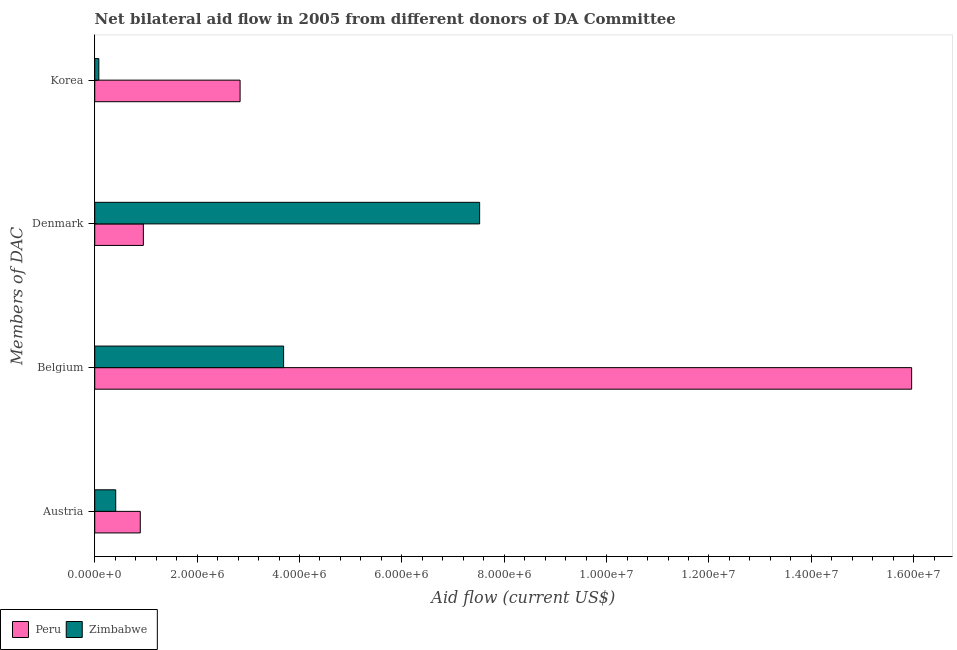How many different coloured bars are there?
Make the answer very short. 2. Are the number of bars per tick equal to the number of legend labels?
Provide a short and direct response. Yes. What is the amount of aid given by austria in Peru?
Make the answer very short. 8.90e+05. Across all countries, what is the maximum amount of aid given by korea?
Make the answer very short. 2.84e+06. Across all countries, what is the minimum amount of aid given by korea?
Your response must be concise. 8.00e+04. In which country was the amount of aid given by korea minimum?
Keep it short and to the point. Zimbabwe. What is the total amount of aid given by austria in the graph?
Ensure brevity in your answer.  1.30e+06. What is the difference between the amount of aid given by belgium in Zimbabwe and that in Peru?
Your answer should be very brief. -1.23e+07. What is the difference between the amount of aid given by korea in Zimbabwe and the amount of aid given by austria in Peru?
Make the answer very short. -8.10e+05. What is the average amount of aid given by denmark per country?
Offer a very short reply. 4.24e+06. What is the difference between the amount of aid given by korea and amount of aid given by austria in Peru?
Your response must be concise. 1.95e+06. In how many countries, is the amount of aid given by belgium greater than 4400000 US$?
Offer a very short reply. 1. What is the ratio of the amount of aid given by denmark in Peru to that in Zimbabwe?
Give a very brief answer. 0.13. Is the amount of aid given by denmark in Zimbabwe less than that in Peru?
Make the answer very short. No. What is the difference between the highest and the second highest amount of aid given by denmark?
Your answer should be compact. 6.57e+06. What is the difference between the highest and the lowest amount of aid given by belgium?
Ensure brevity in your answer.  1.23e+07. Is the sum of the amount of aid given by austria in Zimbabwe and Peru greater than the maximum amount of aid given by denmark across all countries?
Provide a succinct answer. No. What does the 2nd bar from the top in Denmark represents?
Provide a short and direct response. Peru. How many bars are there?
Provide a short and direct response. 8. Are all the bars in the graph horizontal?
Your response must be concise. Yes. What is the difference between two consecutive major ticks on the X-axis?
Make the answer very short. 2.00e+06. Does the graph contain any zero values?
Offer a terse response. No. Does the graph contain grids?
Offer a very short reply. No. Where does the legend appear in the graph?
Provide a short and direct response. Bottom left. How are the legend labels stacked?
Give a very brief answer. Horizontal. What is the title of the graph?
Offer a very short reply. Net bilateral aid flow in 2005 from different donors of DA Committee. Does "Kiribati" appear as one of the legend labels in the graph?
Give a very brief answer. No. What is the label or title of the Y-axis?
Keep it short and to the point. Members of DAC. What is the Aid flow (current US$) of Peru in Austria?
Make the answer very short. 8.90e+05. What is the Aid flow (current US$) in Zimbabwe in Austria?
Provide a short and direct response. 4.10e+05. What is the Aid flow (current US$) in Peru in Belgium?
Offer a very short reply. 1.60e+07. What is the Aid flow (current US$) of Zimbabwe in Belgium?
Make the answer very short. 3.69e+06. What is the Aid flow (current US$) of Peru in Denmark?
Offer a very short reply. 9.50e+05. What is the Aid flow (current US$) of Zimbabwe in Denmark?
Ensure brevity in your answer.  7.52e+06. What is the Aid flow (current US$) in Peru in Korea?
Provide a succinct answer. 2.84e+06. What is the Aid flow (current US$) of Zimbabwe in Korea?
Your answer should be compact. 8.00e+04. Across all Members of DAC, what is the maximum Aid flow (current US$) in Peru?
Your answer should be very brief. 1.60e+07. Across all Members of DAC, what is the maximum Aid flow (current US$) in Zimbabwe?
Ensure brevity in your answer.  7.52e+06. Across all Members of DAC, what is the minimum Aid flow (current US$) of Peru?
Provide a succinct answer. 8.90e+05. Across all Members of DAC, what is the minimum Aid flow (current US$) in Zimbabwe?
Offer a very short reply. 8.00e+04. What is the total Aid flow (current US$) of Peru in the graph?
Your response must be concise. 2.06e+07. What is the total Aid flow (current US$) in Zimbabwe in the graph?
Offer a very short reply. 1.17e+07. What is the difference between the Aid flow (current US$) of Peru in Austria and that in Belgium?
Give a very brief answer. -1.51e+07. What is the difference between the Aid flow (current US$) in Zimbabwe in Austria and that in Belgium?
Offer a terse response. -3.28e+06. What is the difference between the Aid flow (current US$) in Zimbabwe in Austria and that in Denmark?
Your answer should be compact. -7.11e+06. What is the difference between the Aid flow (current US$) of Peru in Austria and that in Korea?
Keep it short and to the point. -1.95e+06. What is the difference between the Aid flow (current US$) in Peru in Belgium and that in Denmark?
Your answer should be very brief. 1.50e+07. What is the difference between the Aid flow (current US$) of Zimbabwe in Belgium and that in Denmark?
Give a very brief answer. -3.83e+06. What is the difference between the Aid flow (current US$) in Peru in Belgium and that in Korea?
Keep it short and to the point. 1.31e+07. What is the difference between the Aid flow (current US$) of Zimbabwe in Belgium and that in Korea?
Give a very brief answer. 3.61e+06. What is the difference between the Aid flow (current US$) of Peru in Denmark and that in Korea?
Give a very brief answer. -1.89e+06. What is the difference between the Aid flow (current US$) in Zimbabwe in Denmark and that in Korea?
Make the answer very short. 7.44e+06. What is the difference between the Aid flow (current US$) of Peru in Austria and the Aid flow (current US$) of Zimbabwe in Belgium?
Your answer should be very brief. -2.80e+06. What is the difference between the Aid flow (current US$) of Peru in Austria and the Aid flow (current US$) of Zimbabwe in Denmark?
Provide a short and direct response. -6.63e+06. What is the difference between the Aid flow (current US$) in Peru in Austria and the Aid flow (current US$) in Zimbabwe in Korea?
Provide a short and direct response. 8.10e+05. What is the difference between the Aid flow (current US$) of Peru in Belgium and the Aid flow (current US$) of Zimbabwe in Denmark?
Provide a succinct answer. 8.44e+06. What is the difference between the Aid flow (current US$) of Peru in Belgium and the Aid flow (current US$) of Zimbabwe in Korea?
Your response must be concise. 1.59e+07. What is the difference between the Aid flow (current US$) of Peru in Denmark and the Aid flow (current US$) of Zimbabwe in Korea?
Provide a short and direct response. 8.70e+05. What is the average Aid flow (current US$) of Peru per Members of DAC?
Keep it short and to the point. 5.16e+06. What is the average Aid flow (current US$) in Zimbabwe per Members of DAC?
Offer a very short reply. 2.92e+06. What is the difference between the Aid flow (current US$) in Peru and Aid flow (current US$) in Zimbabwe in Belgium?
Offer a terse response. 1.23e+07. What is the difference between the Aid flow (current US$) in Peru and Aid flow (current US$) in Zimbabwe in Denmark?
Ensure brevity in your answer.  -6.57e+06. What is the difference between the Aid flow (current US$) in Peru and Aid flow (current US$) in Zimbabwe in Korea?
Give a very brief answer. 2.76e+06. What is the ratio of the Aid flow (current US$) in Peru in Austria to that in Belgium?
Make the answer very short. 0.06. What is the ratio of the Aid flow (current US$) of Peru in Austria to that in Denmark?
Your response must be concise. 0.94. What is the ratio of the Aid flow (current US$) in Zimbabwe in Austria to that in Denmark?
Your response must be concise. 0.05. What is the ratio of the Aid flow (current US$) in Peru in Austria to that in Korea?
Provide a succinct answer. 0.31. What is the ratio of the Aid flow (current US$) in Zimbabwe in Austria to that in Korea?
Ensure brevity in your answer.  5.12. What is the ratio of the Aid flow (current US$) of Peru in Belgium to that in Denmark?
Keep it short and to the point. 16.8. What is the ratio of the Aid flow (current US$) in Zimbabwe in Belgium to that in Denmark?
Give a very brief answer. 0.49. What is the ratio of the Aid flow (current US$) of Peru in Belgium to that in Korea?
Provide a succinct answer. 5.62. What is the ratio of the Aid flow (current US$) in Zimbabwe in Belgium to that in Korea?
Your answer should be very brief. 46.12. What is the ratio of the Aid flow (current US$) of Peru in Denmark to that in Korea?
Keep it short and to the point. 0.33. What is the ratio of the Aid flow (current US$) in Zimbabwe in Denmark to that in Korea?
Provide a short and direct response. 94. What is the difference between the highest and the second highest Aid flow (current US$) of Peru?
Your response must be concise. 1.31e+07. What is the difference between the highest and the second highest Aid flow (current US$) of Zimbabwe?
Make the answer very short. 3.83e+06. What is the difference between the highest and the lowest Aid flow (current US$) of Peru?
Make the answer very short. 1.51e+07. What is the difference between the highest and the lowest Aid flow (current US$) in Zimbabwe?
Ensure brevity in your answer.  7.44e+06. 